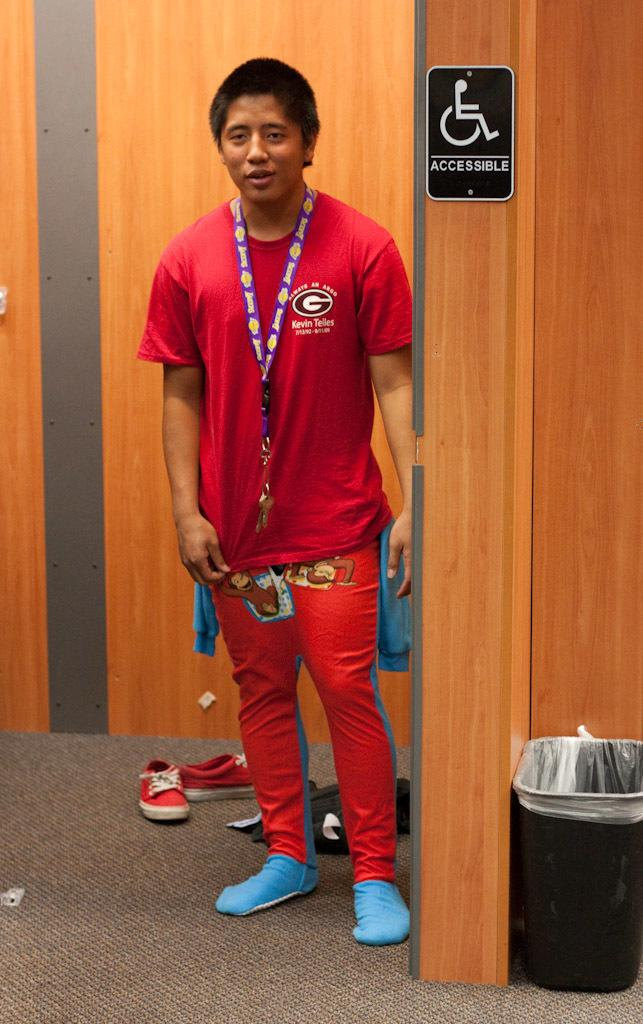Provide a one-sentence caption for the provided image. A man, wearing a red shirt adorned with the letter G, stands next to a sign that says accessible with a picture of a disabled person. 